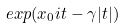<formula> <loc_0><loc_0><loc_500><loc_500>e x p ( x _ { 0 } i t - \gamma | t | )</formula> 